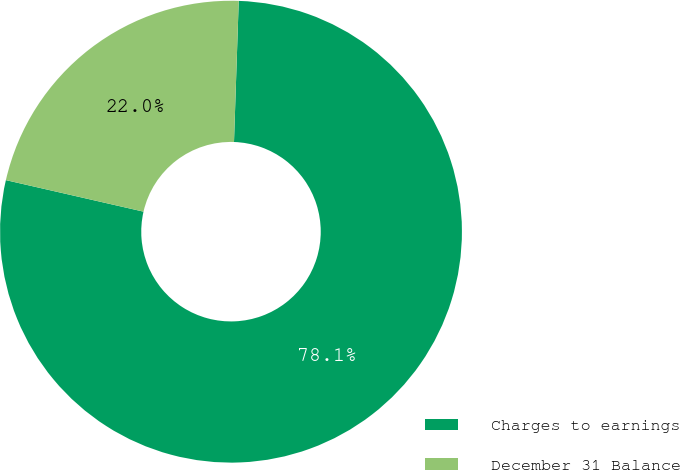<chart> <loc_0><loc_0><loc_500><loc_500><pie_chart><fcel>Charges to earnings<fcel>December 31 Balance<nl><fcel>78.05%<fcel>21.95%<nl></chart> 